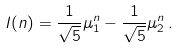<formula> <loc_0><loc_0><loc_500><loc_500>I ( n ) = \frac { 1 } { \sqrt { 5 } } \mu _ { 1 } ^ { n } - \frac { 1 } { \sqrt { 5 } } \mu _ { 2 } ^ { n } \, .</formula> 